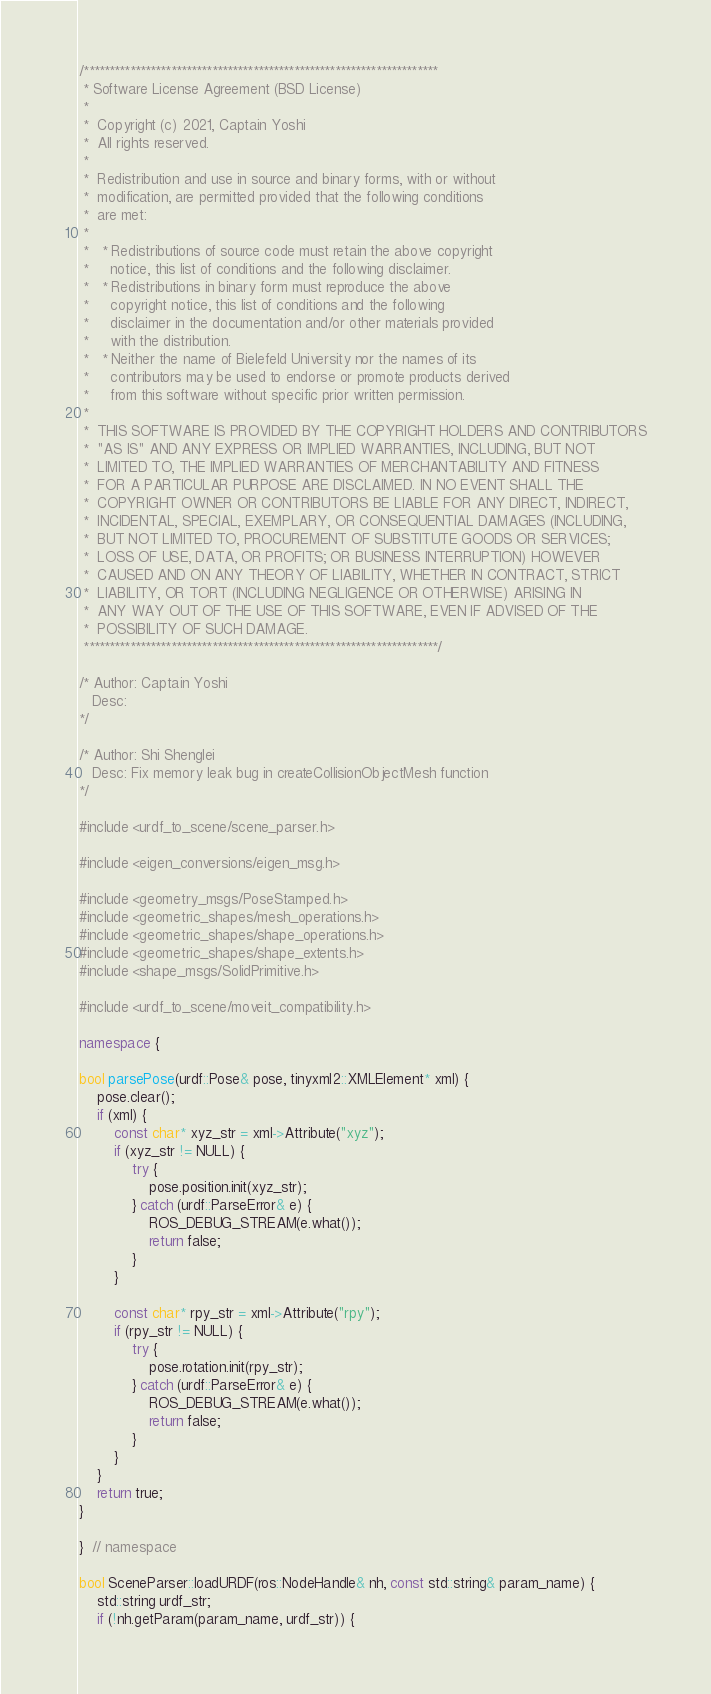Convert code to text. <code><loc_0><loc_0><loc_500><loc_500><_C++_>/*********************************************************************
 * Software License Agreement (BSD License)
 *
 *  Copyright (c) 2021, Captain Yoshi
 *  All rights reserved.
 *
 *  Redistribution and use in source and binary forms, with or without
 *  modification, are permitted provided that the following conditions
 *  are met:
 *
 *   * Redistributions of source code must retain the above copyright
 *     notice, this list of conditions and the following disclaimer.
 *   * Redistributions in binary form must reproduce the above
 *     copyright notice, this list of conditions and the following
 *     disclaimer in the documentation and/or other materials provided
 *     with the distribution.
 *   * Neither the name of Bielefeld University nor the names of its
 *     contributors may be used to endorse or promote products derived
 *     from this software without specific prior written permission.
 *
 *  THIS SOFTWARE IS PROVIDED BY THE COPYRIGHT HOLDERS AND CONTRIBUTORS
 *  "AS IS" AND ANY EXPRESS OR IMPLIED WARRANTIES, INCLUDING, BUT NOT
 *  LIMITED TO, THE IMPLIED WARRANTIES OF MERCHANTABILITY AND FITNESS
 *  FOR A PARTICULAR PURPOSE ARE DISCLAIMED. IN NO EVENT SHALL THE
 *  COPYRIGHT OWNER OR CONTRIBUTORS BE LIABLE FOR ANY DIRECT, INDIRECT,
 *  INCIDENTAL, SPECIAL, EXEMPLARY, OR CONSEQUENTIAL DAMAGES (INCLUDING,
 *  BUT NOT LIMITED TO, PROCUREMENT OF SUBSTITUTE GOODS OR SERVICES;
 *  LOSS OF USE, DATA, OR PROFITS; OR BUSINESS INTERRUPTION) HOWEVER
 *  CAUSED AND ON ANY THEORY OF LIABILITY, WHETHER IN CONTRACT, STRICT
 *  LIABILITY, OR TORT (INCLUDING NEGLIGENCE OR OTHERWISE) ARISING IN
 *  ANY WAY OUT OF THE USE OF THIS SOFTWARE, EVEN IF ADVISED OF THE
 *  POSSIBILITY OF SUCH DAMAGE.
 *********************************************************************/

/* Author: Captain Yoshi
   Desc:
*/

/* Author: Shi Shenglei 
   Desc: Fix memory leak bug in createCollisionObjectMesh function 
*/

#include <urdf_to_scene/scene_parser.h>

#include <eigen_conversions/eigen_msg.h>

#include <geometry_msgs/PoseStamped.h>
#include <geometric_shapes/mesh_operations.h>
#include <geometric_shapes/shape_operations.h>
#include <geometric_shapes/shape_extents.h>
#include <shape_msgs/SolidPrimitive.h>

#include <urdf_to_scene/moveit_compatibility.h>

namespace {

bool parsePose(urdf::Pose& pose, tinyxml2::XMLElement* xml) {
	pose.clear();
	if (xml) {
		const char* xyz_str = xml->Attribute("xyz");
		if (xyz_str != NULL) {
			try {
				pose.position.init(xyz_str);
			} catch (urdf::ParseError& e) {
				ROS_DEBUG_STREAM(e.what());
				return false;
			}
		}

		const char* rpy_str = xml->Attribute("rpy");
		if (rpy_str != NULL) {
			try {
				pose.rotation.init(rpy_str);
			} catch (urdf::ParseError& e) {
				ROS_DEBUG_STREAM(e.what());
				return false;
			}
		}
	}
	return true;
}

}  // namespace

bool SceneParser::loadURDF(ros::NodeHandle& nh, const std::string& param_name) {
	std::string urdf_str;
	if (!nh.getParam(param_name, urdf_str)) {</code> 